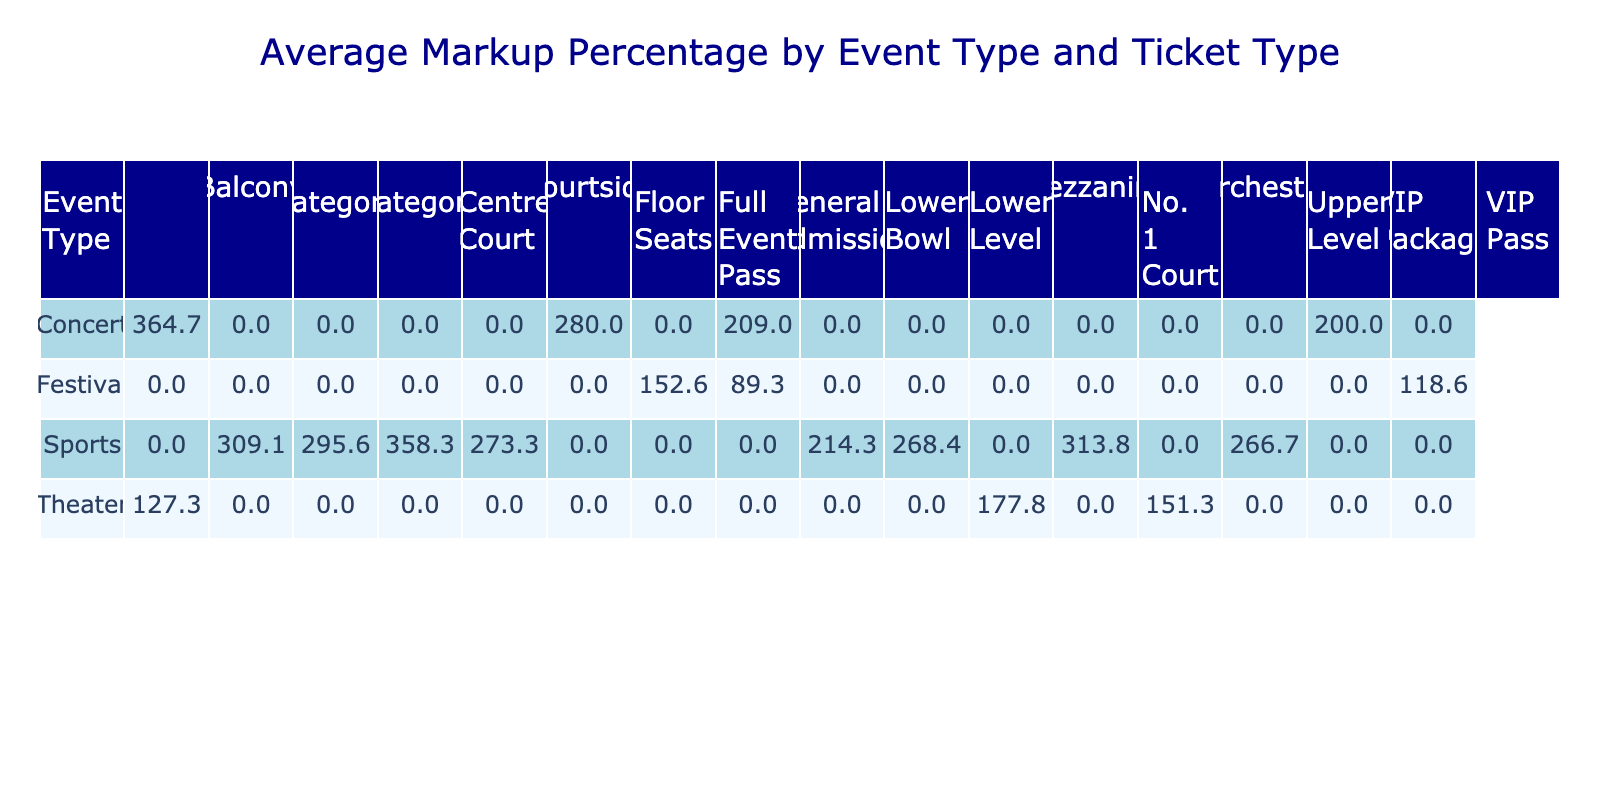What is the average markup percentage for concert VIP packages? Looking at the table under the 'Concert' event type for 'VIP Package', the average markup percentage is calculated from the one data point available: (450 - 150) / 150 * 100 = 200.
Answer: 200.0 Which event type has the highest average resale markup percentage for ticket types? To find this information, I would look at the average markup percentages by event type across all ticket types. By comparing the averages, the 'Sports' event type shows the highest average resale markup percentage, driven primarily by events like the Super Bowl and FIFA World Cup.
Answer: Sports Is the average markup for the general admission tickets across all events greater than 300%? I would check the values in the table for 'General Admission' under each event type. The average markup percentages calculated are 207.1, 256.5, and 57.9 for the different events, totaling a cumulative average markup percentage of significantly less than 300%.
Answer: No What is the difference in average markup percentage between the 'Orchestra' and 'Balcony' ticket types for theater events? First, I take the average markups for 'Orchestra' which is (550 - 199) / 199 * 100 = 176.9%, and for 'Balcony' which is (225 - 99) / 99 * 100 = 127.3%. Then I find the difference: 176.9 - 127.3 = 49.6.
Answer: 49.6 Is there an event type with a markup percentage greater than 400% for any ticket type? By reviewing the table, for the 'FIFA World Cup Final' and the 'Super Bowl LVII', at least one ticket type does exceed a resale markup percentage of 400%. Thus, the statement is true.
Answer: Yes 